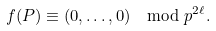<formula> <loc_0><loc_0><loc_500><loc_500>f ( P ) \equiv ( 0 , \dots , 0 ) \mod { p ^ { 2 \ell } } .</formula> 